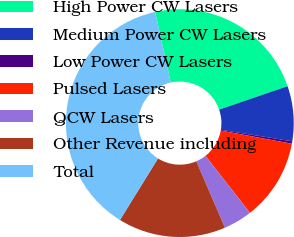Convert chart. <chart><loc_0><loc_0><loc_500><loc_500><pie_chart><fcel>High Power CW Lasers<fcel>Medium Power CW Lasers<fcel>Low Power CW Lasers<fcel>Pulsed Lasers<fcel>QCW Lasers<fcel>Other Revenue including<fcel>Total<nl><fcel>23.23%<fcel>7.81%<fcel>0.34%<fcel>11.55%<fcel>4.08%<fcel>15.29%<fcel>37.71%<nl></chart> 